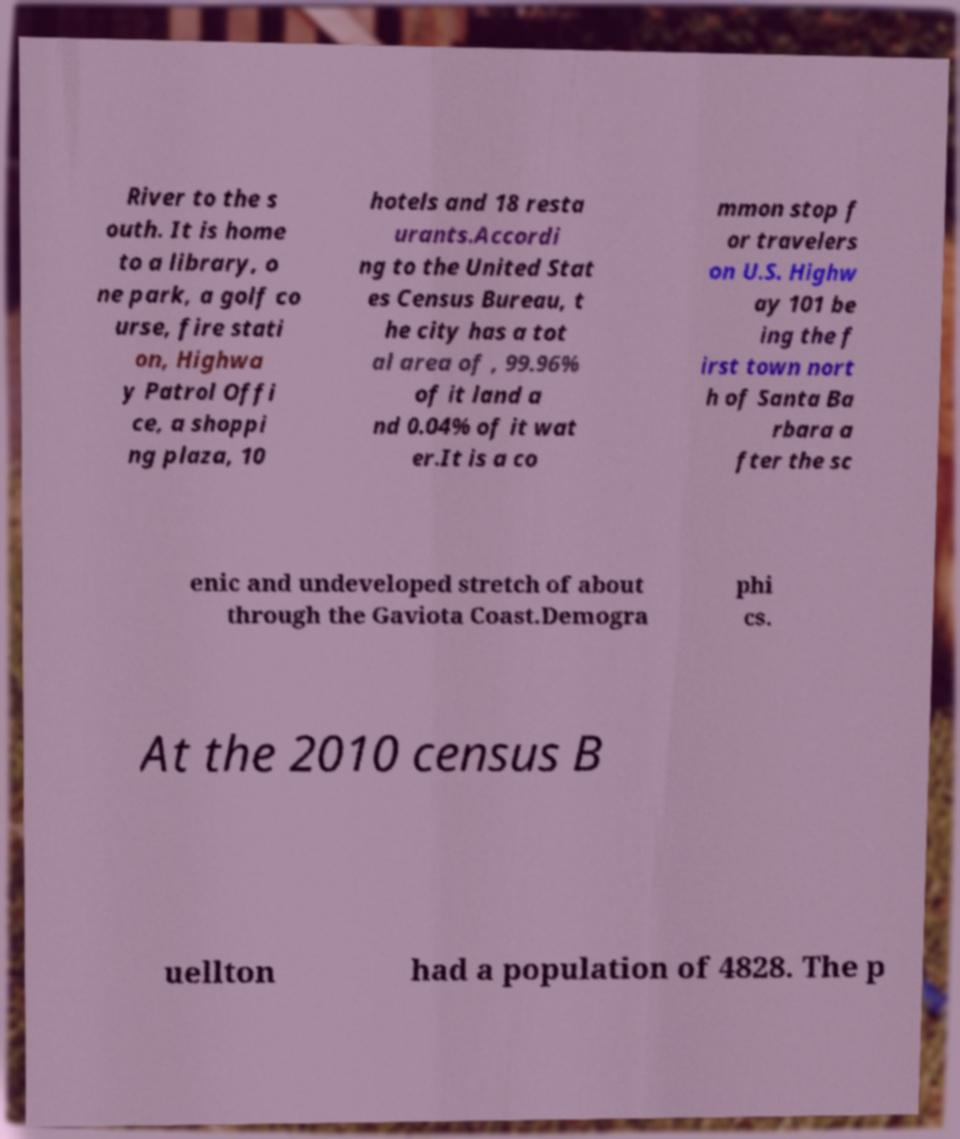Could you extract and type out the text from this image? River to the s outh. It is home to a library, o ne park, a golf co urse, fire stati on, Highwa y Patrol Offi ce, a shoppi ng plaza, 10 hotels and 18 resta urants.Accordi ng to the United Stat es Census Bureau, t he city has a tot al area of , 99.96% of it land a nd 0.04% of it wat er.It is a co mmon stop f or travelers on U.S. Highw ay 101 be ing the f irst town nort h of Santa Ba rbara a fter the sc enic and undeveloped stretch of about through the Gaviota Coast.Demogra phi cs. At the 2010 census B uellton had a population of 4828. The p 